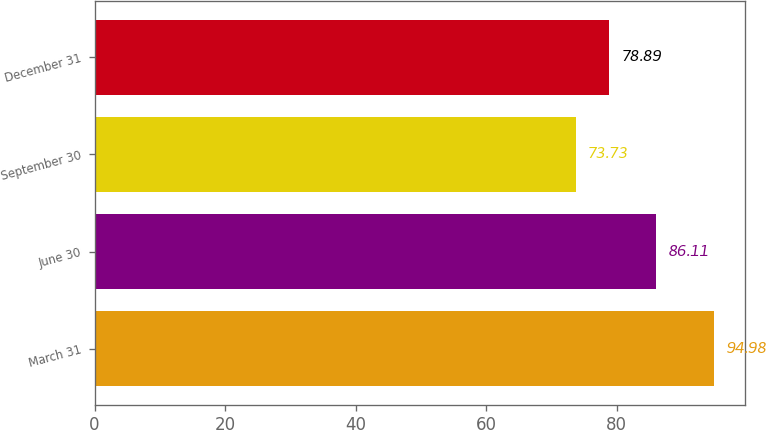<chart> <loc_0><loc_0><loc_500><loc_500><bar_chart><fcel>March 31<fcel>June 30<fcel>September 30<fcel>December 31<nl><fcel>94.98<fcel>86.11<fcel>73.73<fcel>78.89<nl></chart> 